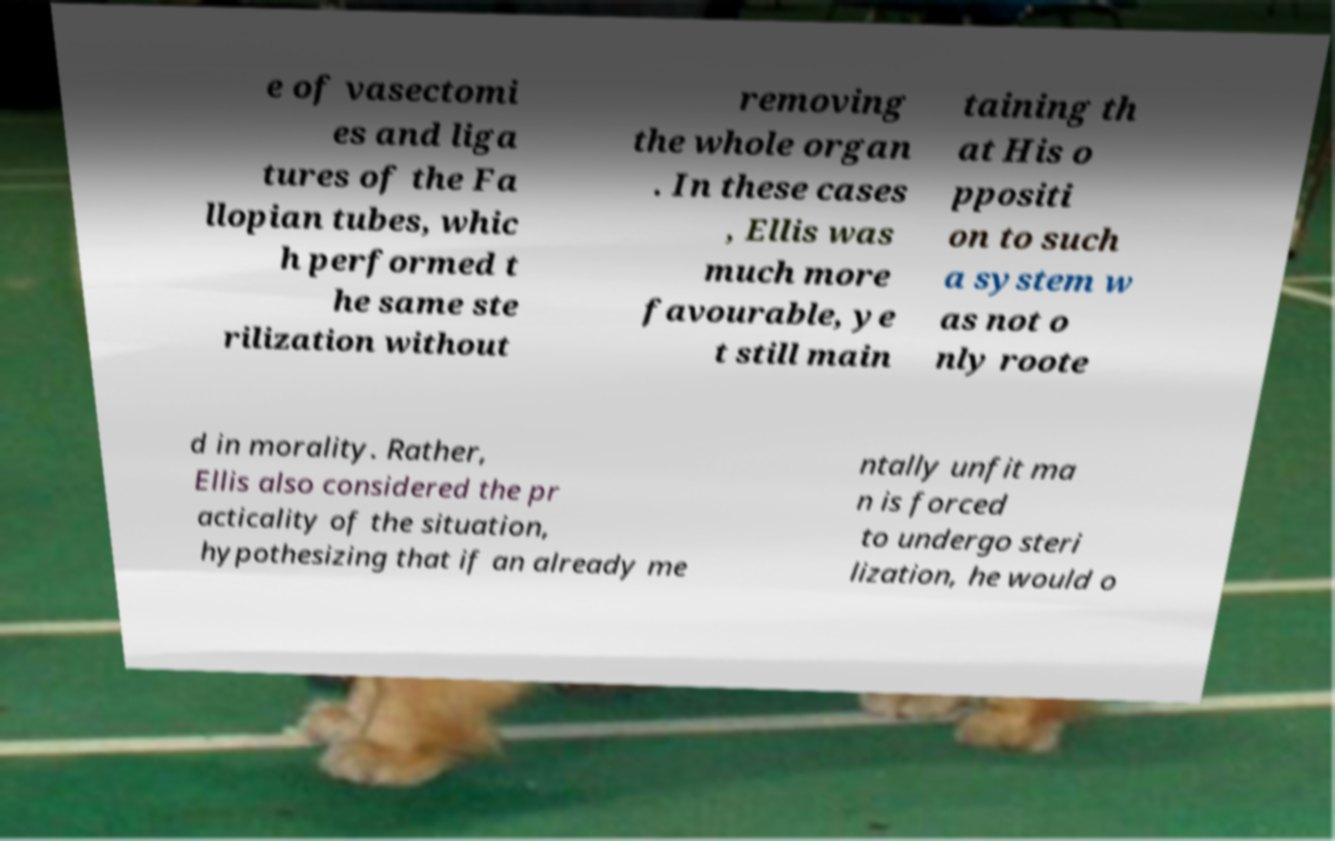I need the written content from this picture converted into text. Can you do that? e of vasectomi es and liga tures of the Fa llopian tubes, whic h performed t he same ste rilization without removing the whole organ . In these cases , Ellis was much more favourable, ye t still main taining th at His o ppositi on to such a system w as not o nly roote d in morality. Rather, Ellis also considered the pr acticality of the situation, hypothesizing that if an already me ntally unfit ma n is forced to undergo steri lization, he would o 